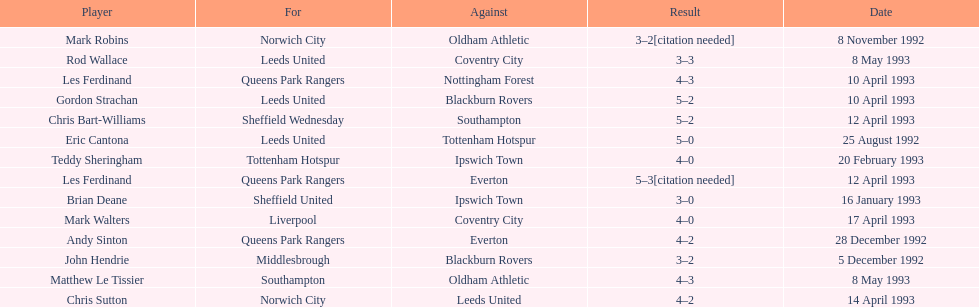Name the only player from france. Eric Cantona. 